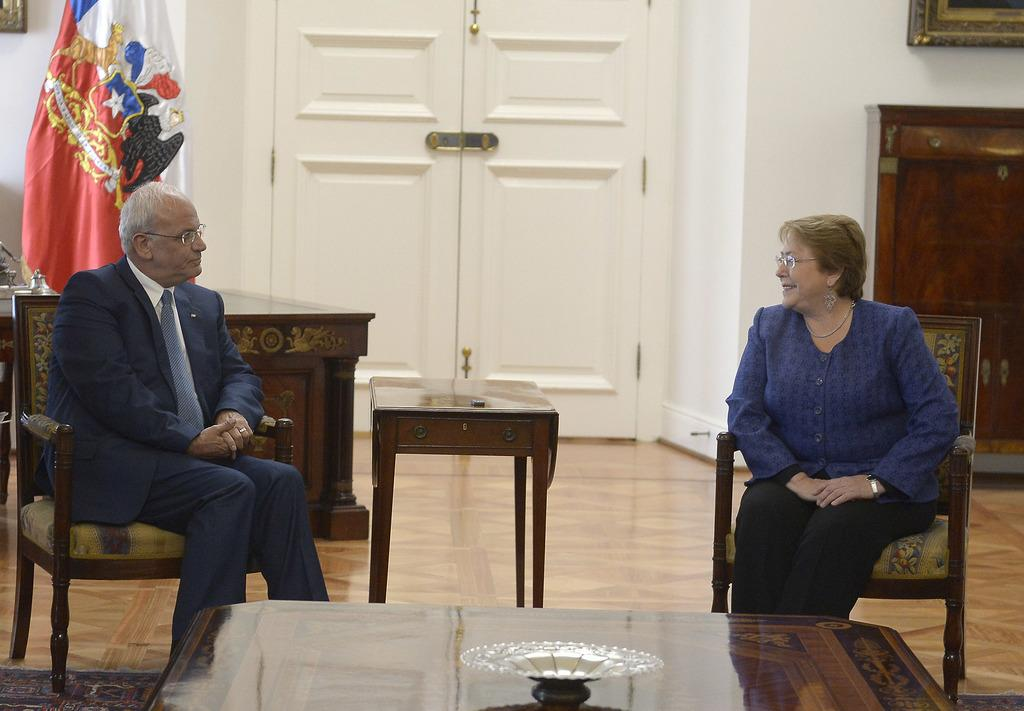How many people are sitting in the image? There are 2 people sitting on chairs in the image. What is in front of the chairs? There is a table in front of the chairs. What can be seen behind the chairs? There is a white door behind the chairs. Where is the flag located in the image? The flag is in the left corner of the image. What type of trouble is the police officer causing in the image? There is no police officer present in the image, and therefore no trouble can be observed. 